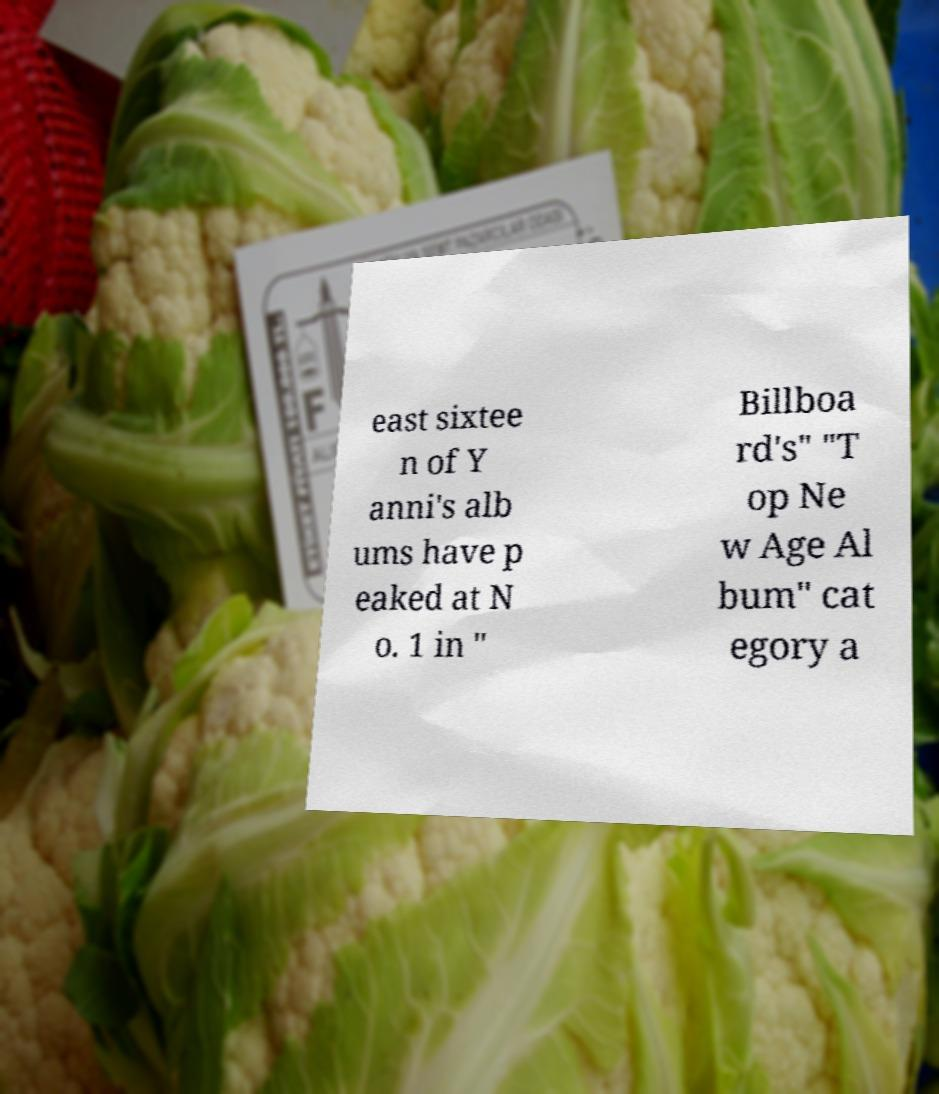Please read and relay the text visible in this image. What does it say? east sixtee n of Y anni's alb ums have p eaked at N o. 1 in " Billboa rd's" "T op Ne w Age Al bum" cat egory a 